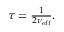<formula> <loc_0><loc_0><loc_500><loc_500>\begin{array} { r } \tau = \frac { 1 } { 2 \nu _ { e f f } } . } \end{array}</formula> 